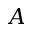Convert formula to latex. <formula><loc_0><loc_0><loc_500><loc_500>A</formula> 